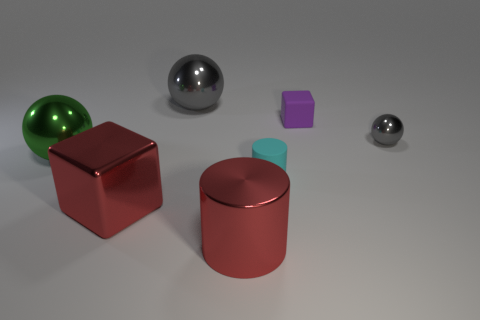Does the cylinder in front of the large shiny block have the same material as the red cube?
Keep it short and to the point. Yes. There is a large object behind the object that is on the right side of the purple thing; what is its material?
Your response must be concise. Metal. What number of big red shiny things have the same shape as the cyan rubber thing?
Make the answer very short. 1. There is a metallic object on the right side of the tiny matte object in front of the shiny sphere that is in front of the tiny gray ball; what size is it?
Ensure brevity in your answer.  Small. How many cyan things are either matte cylinders or big cylinders?
Your response must be concise. 1. There is a large gray object to the right of the big red shiny cube; is its shape the same as the small purple matte object?
Your answer should be compact. No. Is the number of big green balls in front of the small gray thing greater than the number of green cylinders?
Provide a short and direct response. Yes. How many purple rubber objects are the same size as the purple rubber cube?
Provide a short and direct response. 0. What is the size of the metallic thing that is the same color as the shiny block?
Ensure brevity in your answer.  Large. What number of things are either large red metallic objects or big objects that are to the left of the large gray thing?
Your answer should be very brief. 3. 